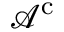<formula> <loc_0><loc_0><loc_500><loc_500>{ \mathcal { A } } ^ { c }</formula> 